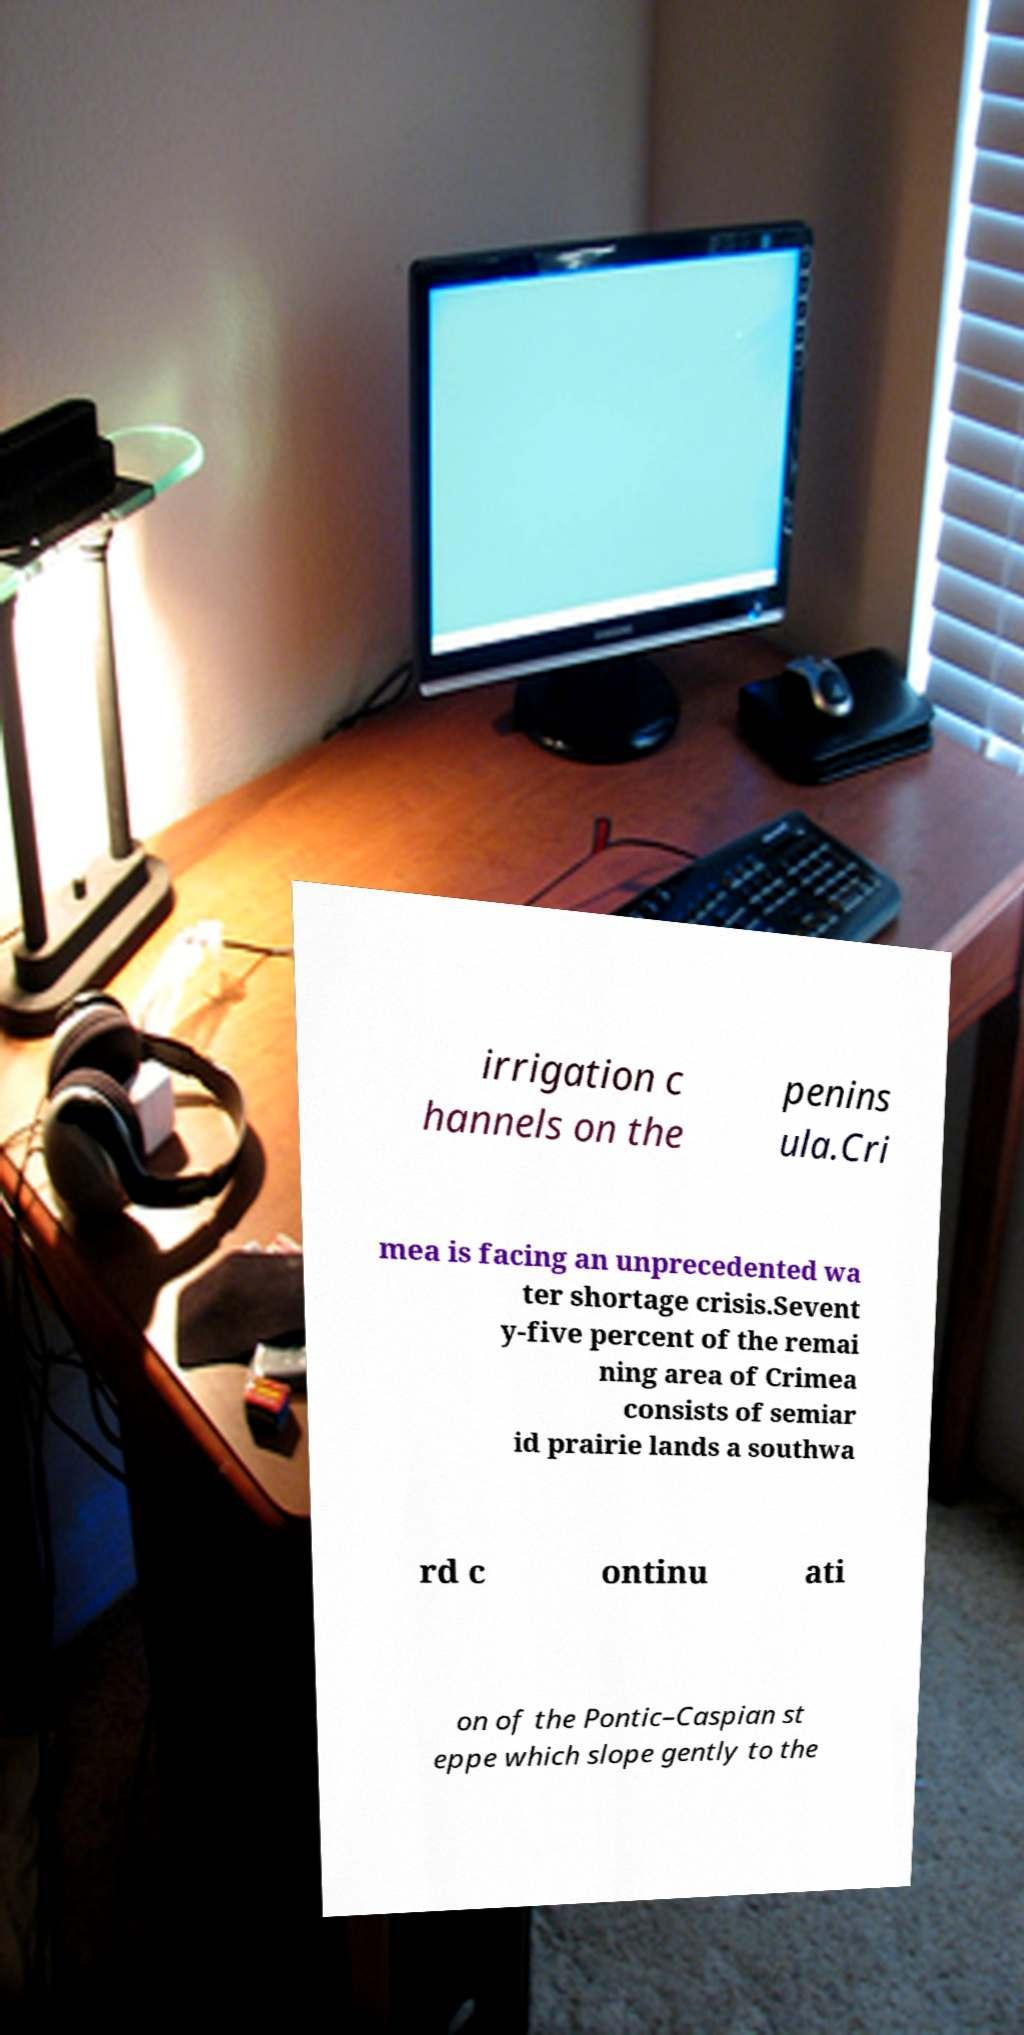There's text embedded in this image that I need extracted. Can you transcribe it verbatim? irrigation c hannels on the penins ula.Cri mea is facing an unprecedented wa ter shortage crisis.Sevent y-five percent of the remai ning area of Crimea consists of semiar id prairie lands a southwa rd c ontinu ati on of the Pontic–Caspian st eppe which slope gently to the 